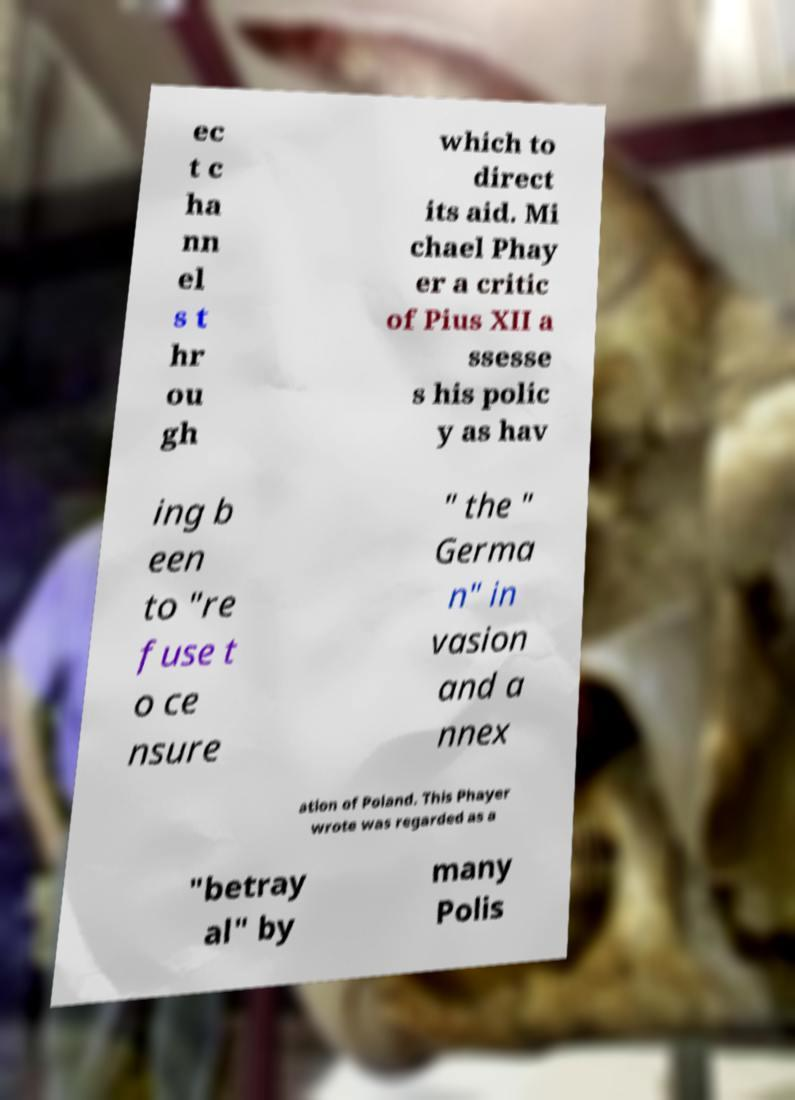I need the written content from this picture converted into text. Can you do that? ec t c ha nn el s t hr ou gh which to direct its aid. Mi chael Phay er a critic of Pius XII a ssesse s his polic y as hav ing b een to "re fuse t o ce nsure " the " Germa n" in vasion and a nnex ation of Poland. This Phayer wrote was regarded as a "betray al" by many Polis 